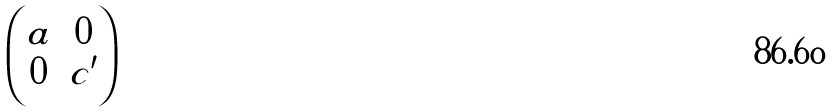Convert formula to latex. <formula><loc_0><loc_0><loc_500><loc_500>\begin{pmatrix} a & 0 \\ 0 & c ^ { \prime } \end{pmatrix}</formula> 